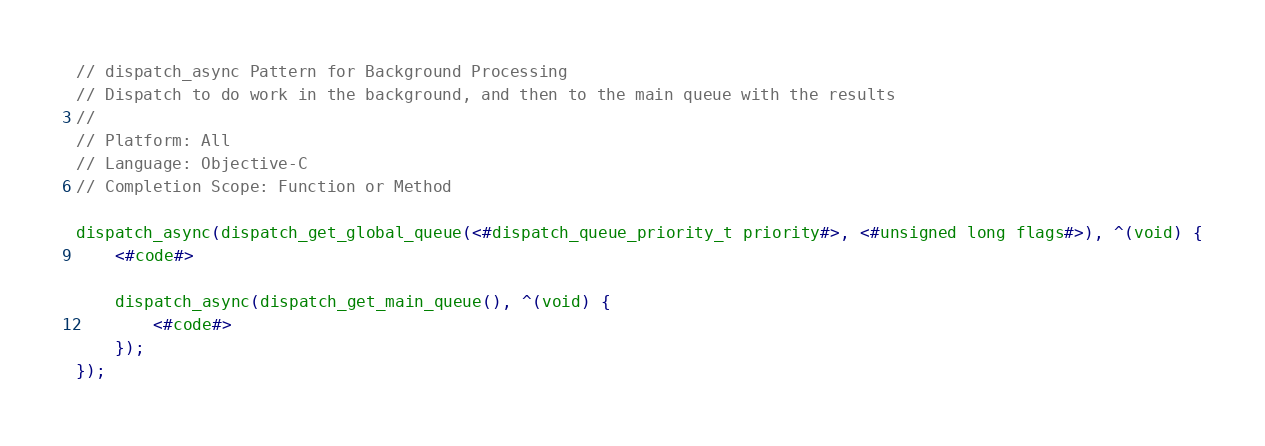<code> <loc_0><loc_0><loc_500><loc_500><_Rust_>// dispatch_async Pattern for Background Processing
// Dispatch to do work in the background, and then to the main queue with the results
// 
// Platform: All
// Language: Objective-C
// Completion Scope: Function or Method

dispatch_async(dispatch_get_global_queue(<#dispatch_queue_priority_t priority#>, <#unsigned long flags#>), ^(void) {
    <#code#>
    
    dispatch_async(dispatch_get_main_queue(), ^(void) {
        <#code#>
    });
});
</code> 